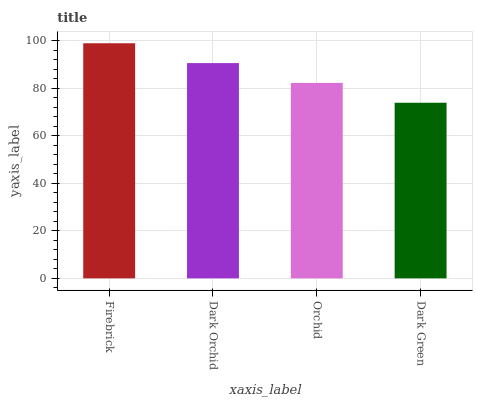Is Dark Green the minimum?
Answer yes or no. Yes. Is Firebrick the maximum?
Answer yes or no. Yes. Is Dark Orchid the minimum?
Answer yes or no. No. Is Dark Orchid the maximum?
Answer yes or no. No. Is Firebrick greater than Dark Orchid?
Answer yes or no. Yes. Is Dark Orchid less than Firebrick?
Answer yes or no. Yes. Is Dark Orchid greater than Firebrick?
Answer yes or no. No. Is Firebrick less than Dark Orchid?
Answer yes or no. No. Is Dark Orchid the high median?
Answer yes or no. Yes. Is Orchid the low median?
Answer yes or no. Yes. Is Orchid the high median?
Answer yes or no. No. Is Dark Orchid the low median?
Answer yes or no. No. 